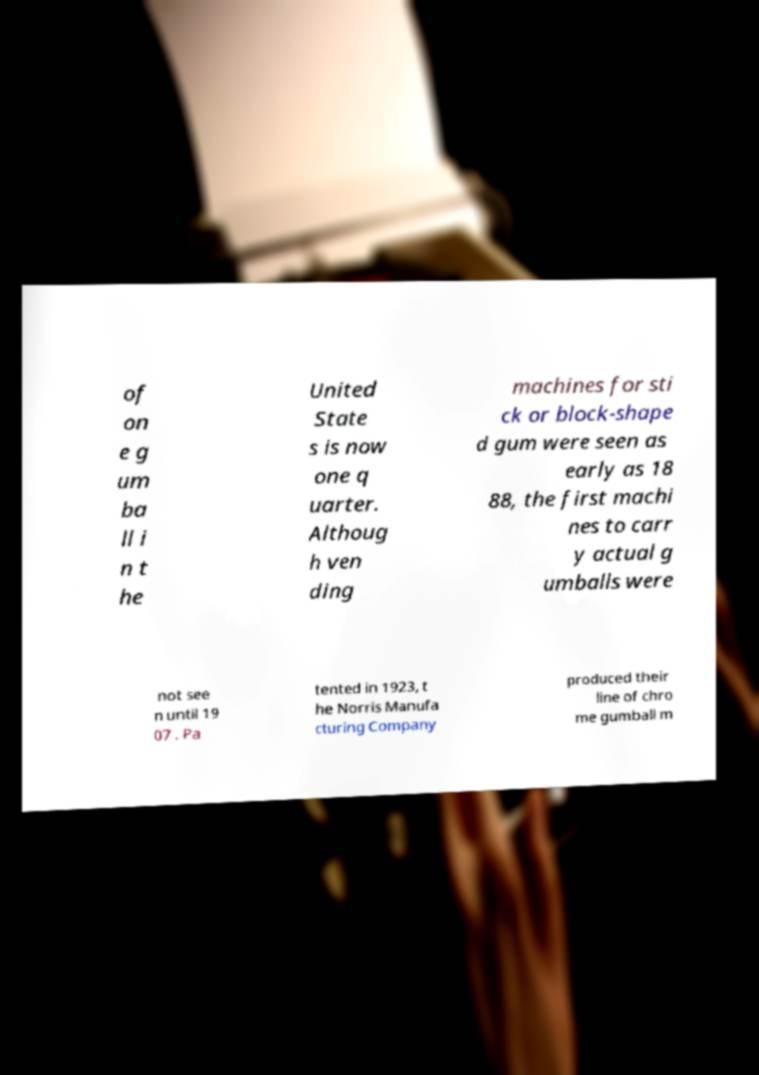Please read and relay the text visible in this image. What does it say? of on e g um ba ll i n t he United State s is now one q uarter. Althoug h ven ding machines for sti ck or block-shape d gum were seen as early as 18 88, the first machi nes to carr y actual g umballs were not see n until 19 07 . Pa tented in 1923, t he Norris Manufa cturing Company produced their line of chro me gumball m 